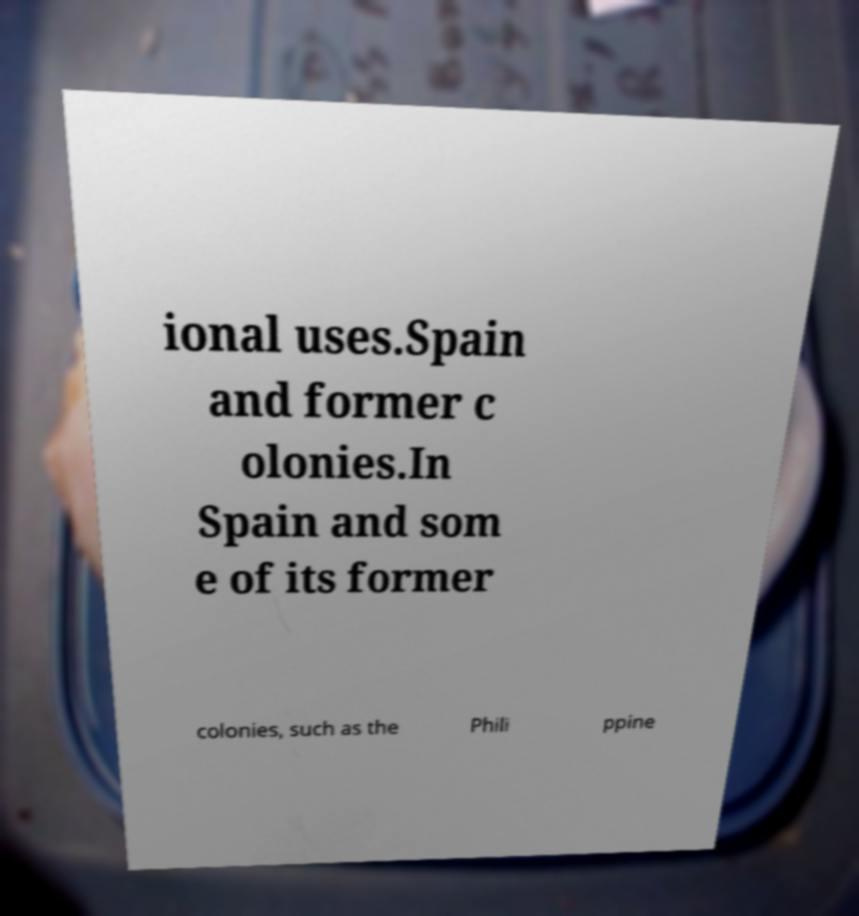Can you accurately transcribe the text from the provided image for me? ional uses.Spain and former c olonies.In Spain and som e of its former colonies, such as the Phili ppine 